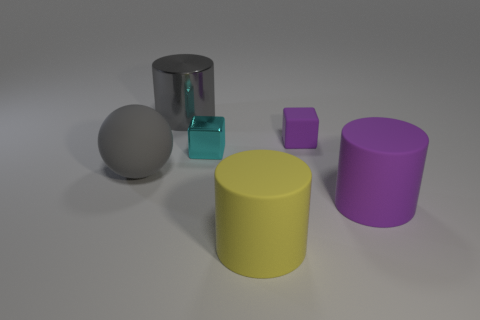Are there more big cylinders in front of the tiny purple thing than metal cubes left of the metallic cylinder?
Keep it short and to the point. Yes. The cylinder that is behind the purple rubber thing in front of the big gray rubber object is what color?
Keep it short and to the point. Gray. Does the yellow cylinder have the same material as the purple block?
Keep it short and to the point. Yes. Is there a tiny cyan object of the same shape as the small purple rubber thing?
Give a very brief answer. Yes. There is a large matte object that is behind the purple cylinder; is it the same color as the big metal cylinder?
Provide a succinct answer. Yes. There is a block that is on the left side of the yellow cylinder; is its size the same as the thing that is on the right side of the small rubber thing?
Offer a terse response. No. The purple cube that is made of the same material as the gray sphere is what size?
Your answer should be very brief. Small. How many purple matte things are behind the gray ball and in front of the gray matte sphere?
Your response must be concise. 0. How many things are small rubber balls or large rubber objects that are on the right side of the gray cylinder?
Provide a succinct answer. 2. What is the shape of the matte thing that is the same color as the large metal cylinder?
Give a very brief answer. Sphere. 